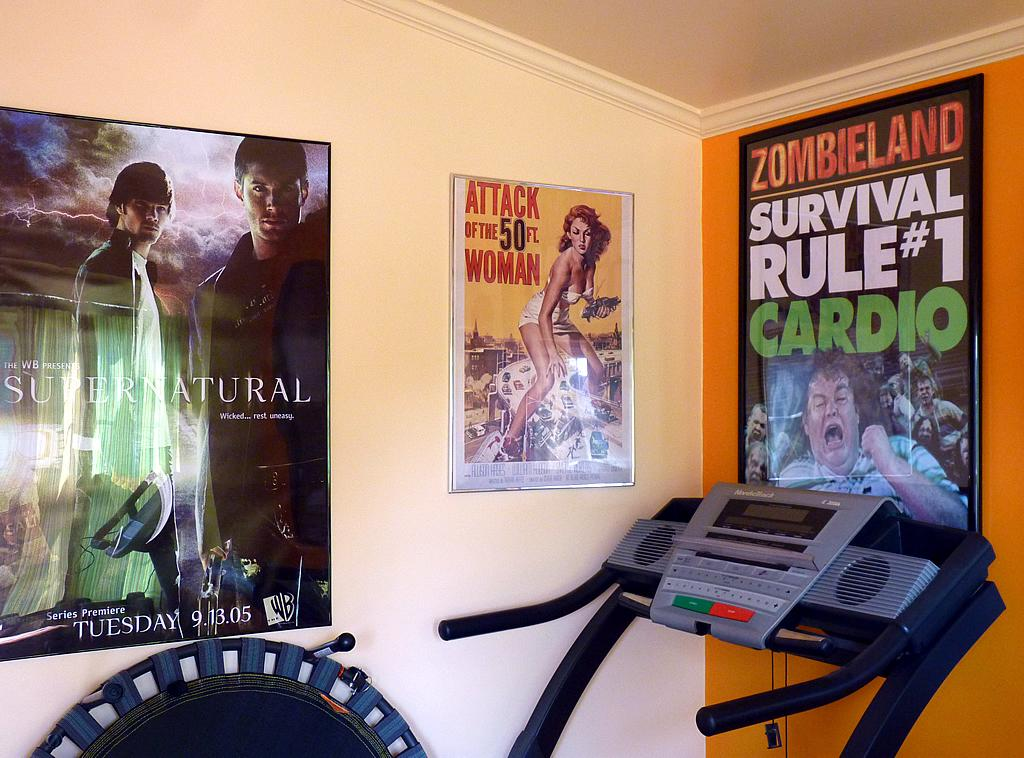What is on the wall in the image? There are posters on the wall in the image. What type of exercise equipment is present in the image? There is a treadmill in the image. What feature does the treadmill have? The treadmill has buttons. How many gloves are being tested on the treadmill in the image? There are no gloves present in the image, and therefore no testing is taking place. What type of finger movements are required to operate the treadmill in the image? The treadmill in the image is operated using buttons, not finger movements. 